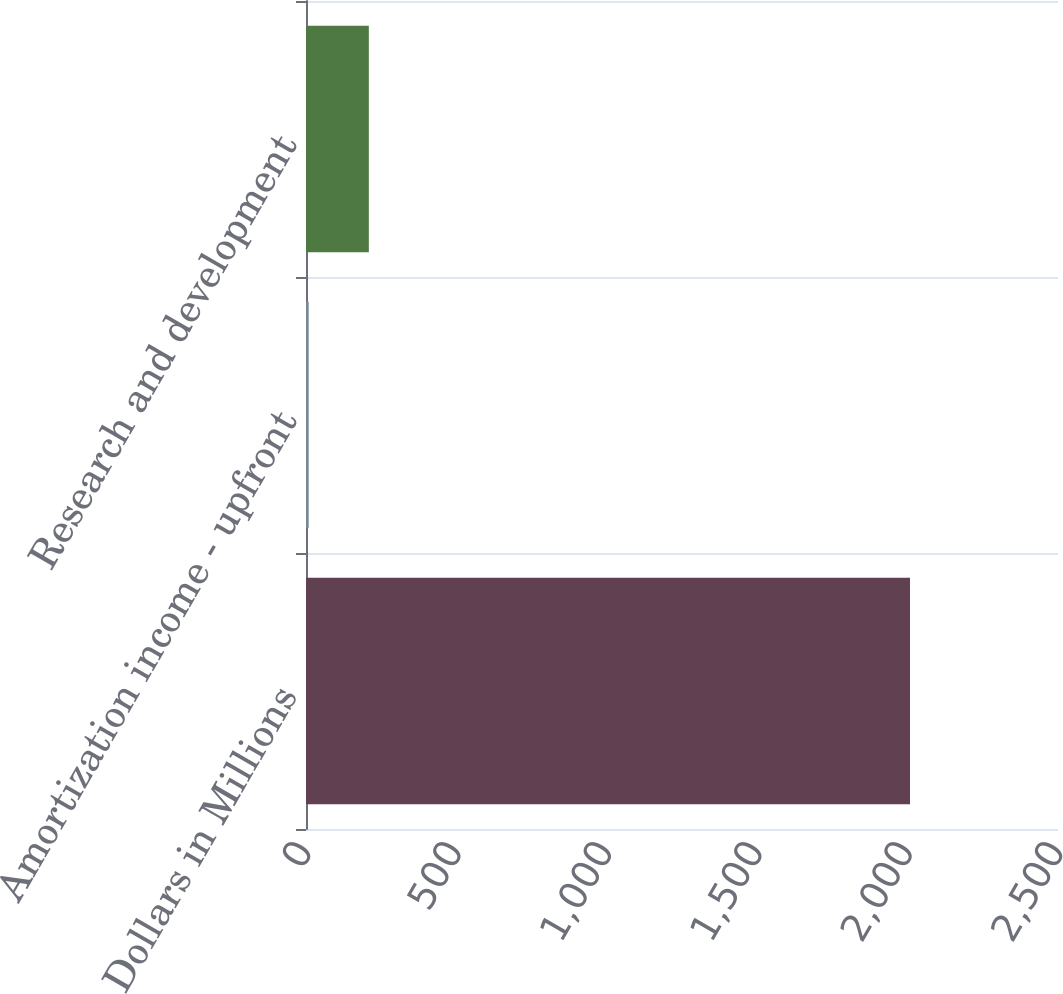Convert chart to OTSL. <chart><loc_0><loc_0><loc_500><loc_500><bar_chart><fcel>Dollars in Millions<fcel>Amortization income - upfront<fcel>Research and development<nl><fcel>2008<fcel>9<fcel>208.9<nl></chart> 